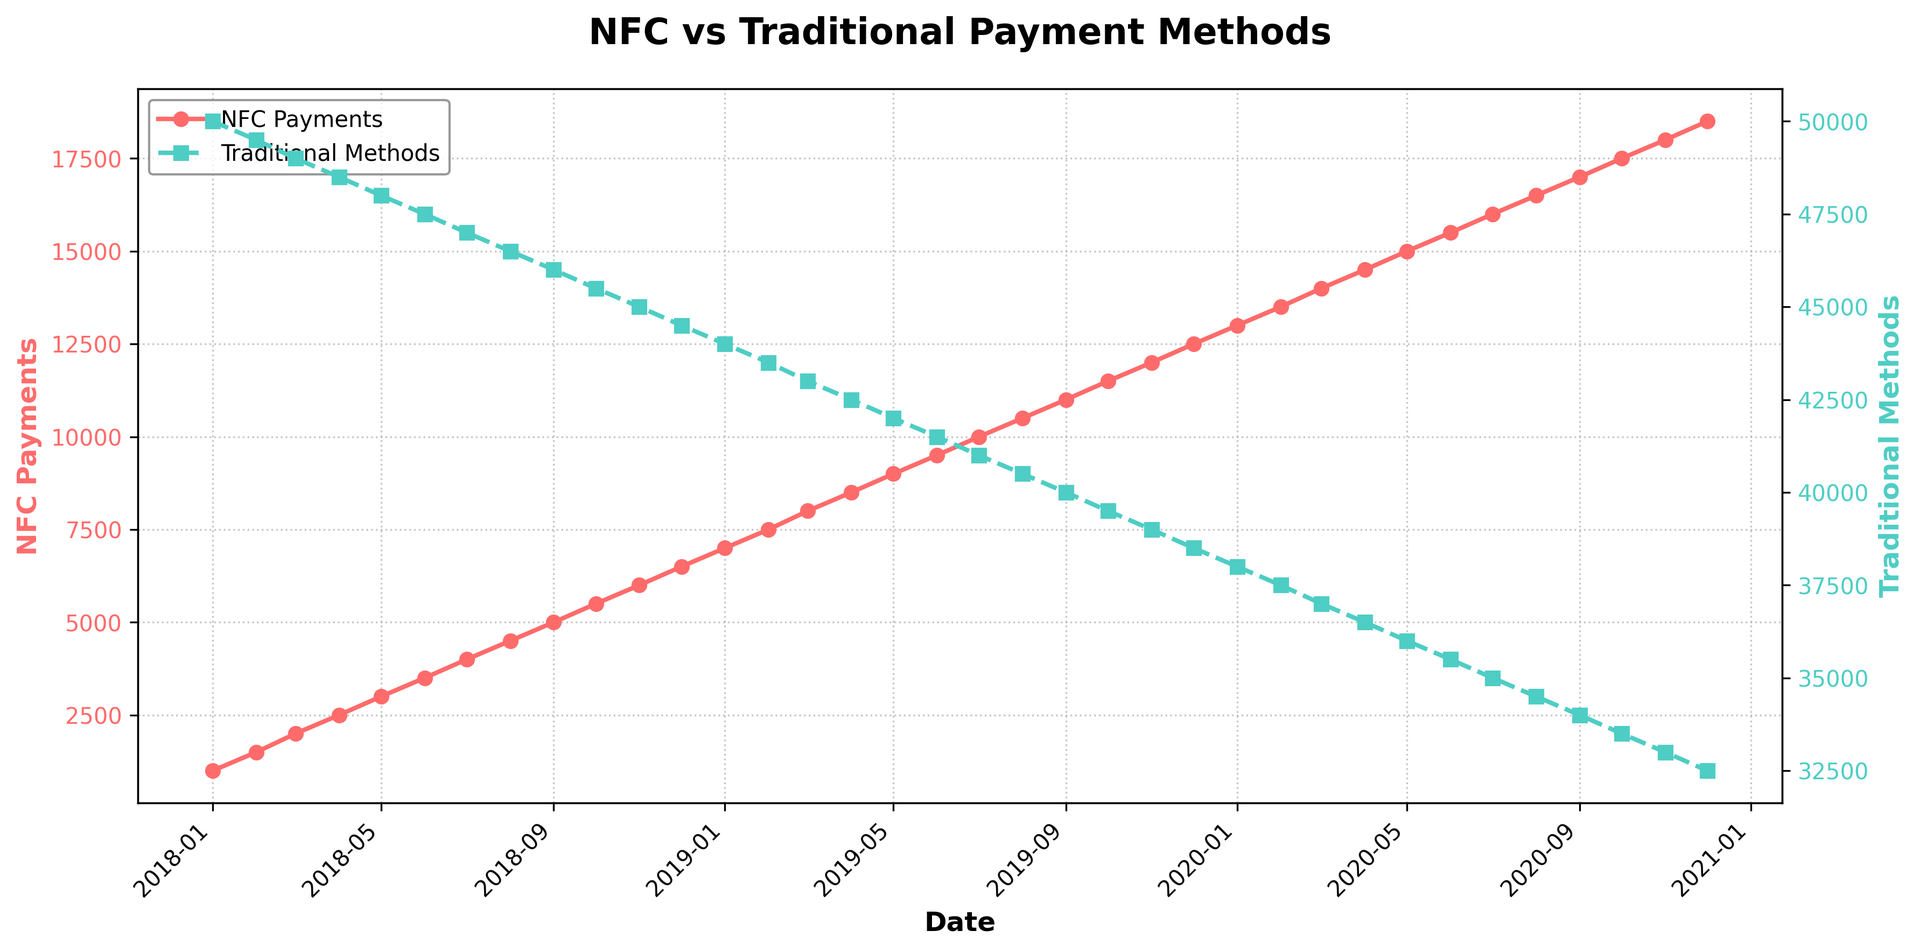What is the trend of NFC payments from Jan 2018 to Dec 2020? By observing the figure, we see that the NFC payments line is sloping upwards consistently from Jan 2018 to Dec 2020, indicating an increasing trend.
Answer: Increasing How do the transaction volumes of NFC payments compare to traditional methods in Dec 2020? In Dec 2020, the NFC payments are at 18,500, whereas traditional methods are at 32,500. NFC payments are significantly lower than traditional methods.
Answer: NFC payments are lower What is the difference in transaction volume between NFC payments and traditional methods in Jun 2019? In Jun 2019, NFC payments are 9,500 and traditional methods are 41,500. The difference is 41,500 - 9,500.
Answer: 32,000 When did NFC payments first exceed 10,000 transactions? By observing the NFC payments line, we see that transactions first exceeded 10,000 in Jul 2019.
Answer: Jul 2019 What is the average monthly transaction volume of NFC payments in 2019? Sum all NFC payments from Jan 2019 to Dec 2019 and divide by 12. (7,000 + 7,500 + 8,000 + 8,500 + 9,000 + 9,500 + 10,000 + 10,500 + 11,000 + 11,500 + 12,000 + 12,500) / 12 = 9,750
Answer: 9,750 On average, by how much did NFC payments increase each month in 2020? Calculate the difference between Dec 2020 and Jan 2020 NFC payments, then divide by 11. (18,500 - 13,000) / 11 = 5,500 / 11 = 500
Answer: 500 Which method had a more significant change in transaction volume from Jan 2018 to Dec 2020? NFC Payments increased from 1,000 to 18,500, a change of 17,500. Traditional Methods decreased from 50,000 to 32,500, a change of 17,500.
Answer: Same significant change How do the colors represent the different payment methods in the figure? NFC payments are represented by a solid red line with circle markers, and traditional methods by a dashed green line with square markers.
Answer: NFC is red, Traditional is green Which month saw the smallest difference in transaction volume between NFC payments and traditional methods? By comparing each month, we find the smallest difference is in Dec 2020, with a difference of 14,000 (32500 - 18500).
Answer: Dec 2020 